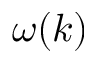<formula> <loc_0><loc_0><loc_500><loc_500>\omega ( k )</formula> 